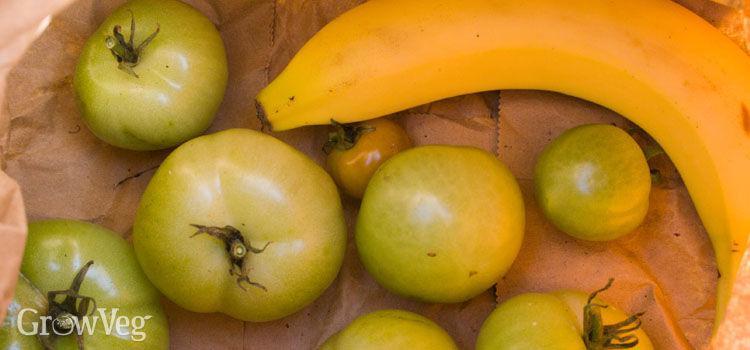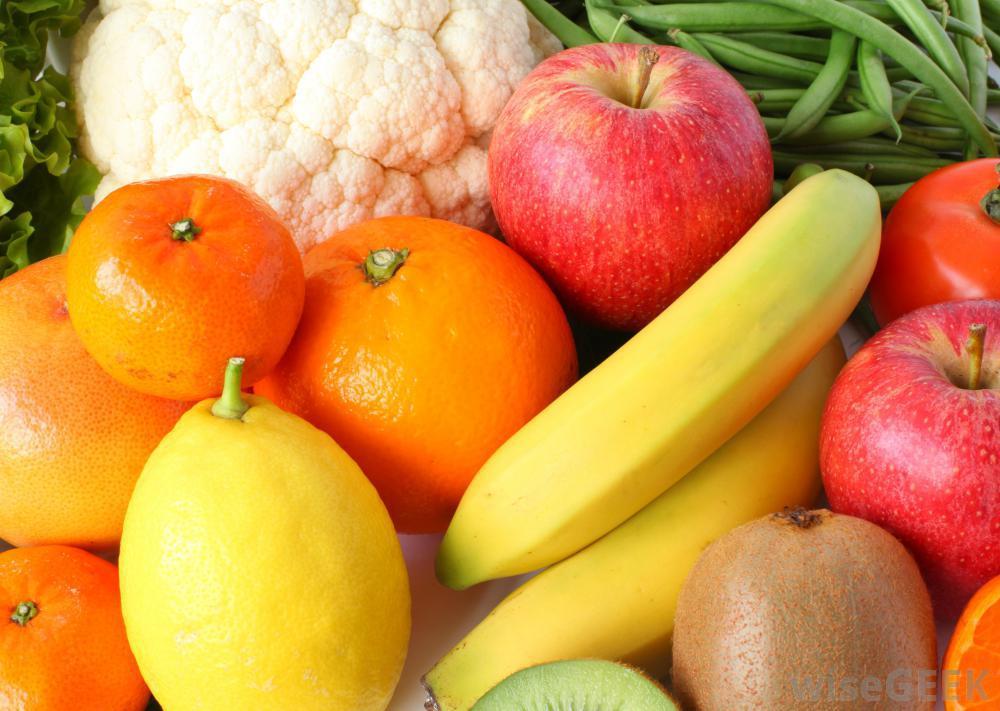The first image is the image on the left, the second image is the image on the right. For the images displayed, is the sentence "An image shows at least one banana posed with at least six red tomatoes, and no other produce items." factually correct? Answer yes or no. No. The first image is the image on the left, the second image is the image on the right. For the images shown, is this caption "In one image, at least one banana is lying flat in an arrangement with at least seven red tomatoes that do not have any stems." true? Answer yes or no. No. 